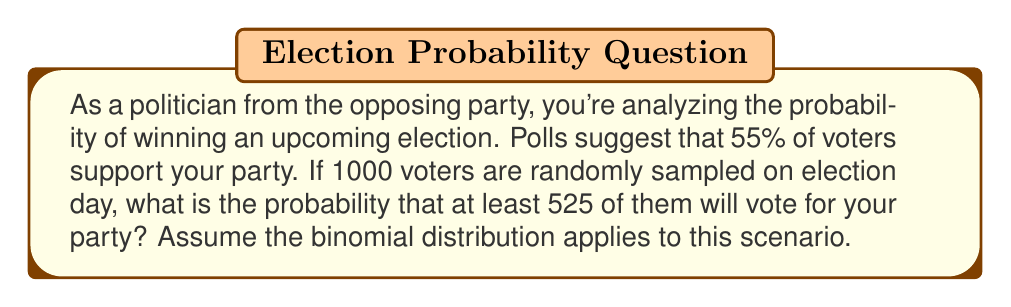Solve this math problem. To solve this problem, we'll use the binomial distribution and the concept of cumulative probability. Let's break it down step-by-step:

1) First, let's identify the parameters of our binomial distribution:
   $n = 1000$ (number of trials)
   $p = 0.55$ (probability of success on each trial)
   $X$ = number of successes (voters supporting your party)

2) We want to find $P(X \geq 525)$

3) It's often easier to calculate the complement of this probability:
   $P(X \geq 525) = 1 - P(X < 525) = 1 - P(X \leq 524)$

4) The probability $P(X \leq 524)$ can be calculated using the cumulative binomial distribution function. However, for large $n$, we can approximate the binomial distribution with a normal distribution:

   $X \sim N(\mu, \sigma^2)$, where:
   $\mu = np = 1000 \cdot 0.55 = 550$
   $\sigma^2 = np(1-p) = 1000 \cdot 0.55 \cdot 0.45 = 247.5$
   $\sigma = \sqrt{247.5} \approx 15.73$

5) We need to apply a continuity correction when using the normal approximation. So instead of 524, we use 524.5:

   $P(X \leq 524) \approx P(Z \leq \frac{524.5 - 550}{15.73})$

6) Calculate the Z-score:
   $Z = \frac{524.5 - 550}{15.73} \approx -1.62$

7) Using a standard normal distribution table or calculator, we can find:
   $P(Z \leq -1.62) \approx 0.0526$

8) Therefore, $P(X \geq 525) = 1 - P(X \leq 524) \approx 1 - 0.0526 = 0.9474$
Answer: The probability that at least 525 out of 1000 randomly sampled voters will vote for your party is approximately 0.9474 or 94.74%. 